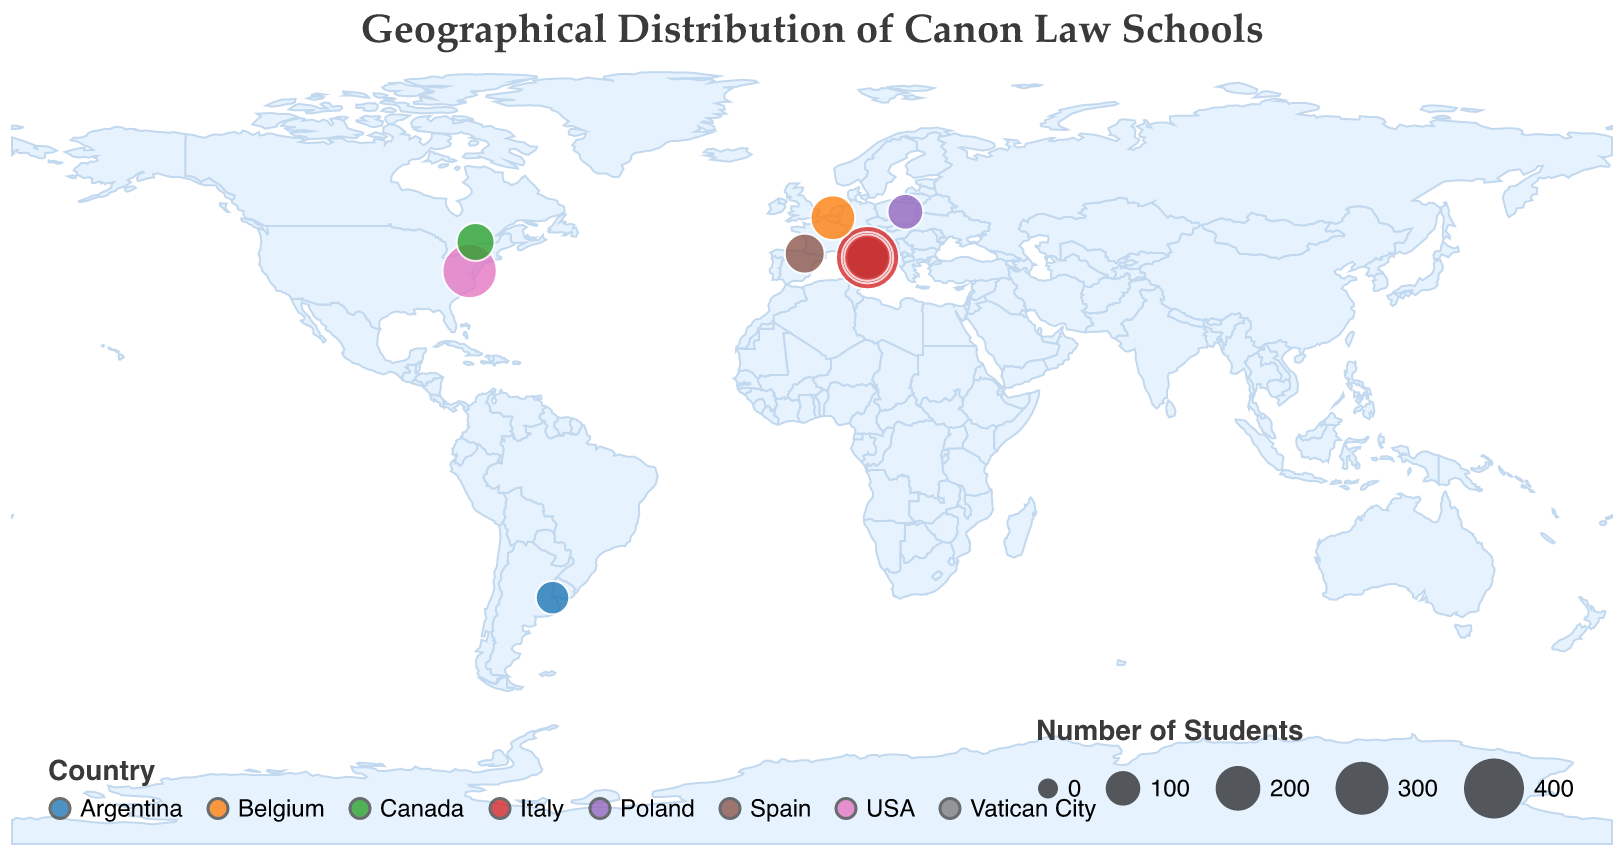What is the title of the figure? The title is displayed prominently at the top of the figure, written in a larger font size.
Answer: Geographical Distribution of Canon Law Schools Which institution has the highest number of students? The size of the circles represents the number of students, and the largest circle indicates the institution with the most students.
Answer: Pontifical Gregorian University How many institutions are located in Rome, Italy? By counting the circles located at the coordinates corresponding to Rome, Italy, we can determine the number of institutions in that city. There are four such circles.
Answer: 4 What is the total number of students in institutions located in Rome, Italy? Add the number of students for the four institutions in Rome: Pontifical Gregorian University (450), Pontifical University of the Holy Cross (280), Pontifical Lateran University (180), and Pontifical University of Saint Thomas Aquinas (220).
Answer: 1130 Which country has the second highest number of represented institutions in the given data set? By counting the number of different institutions listed under each country, we can determine which country has the second highest representation. Italy has the highest, and the USA is next.
Answer: USA Which institution is represented with the smallest circle? The smallest circle represents the institution with the fewest students, which is indicated by the size of the circle.
Answer: Pontifical Catholic University of Argentina How many institutions are represented in North America? Identify the circles located in North America, which includes the USA and Canada, and count them. There are two institutions: one in Washington D.C. and one in Ottawa.
Answer: 2 Which country shows the most diverse distribution of circle sizes? By visually comparing the range of circle sizes within each country, we can determine which country has the most diverse distribution. Italy has a wide range of circle sizes.
Answer: Italy What is the approximate latitude and longitude of the University of Navarra? Find the circle representing the University of Navarra and note its geographical coordinates. They match the given latitude and longitude values for Pamplona, Spain.
Answer: 42.8125, -1.6458 Comparing the number of students between University of Warsaw and Université Saint-Paul, which institution has more students? Consult the data points for these institutions: University of Warsaw has 110 students, and Université Saint-Paul has 130 students.
Answer: Université Saint-Paul 